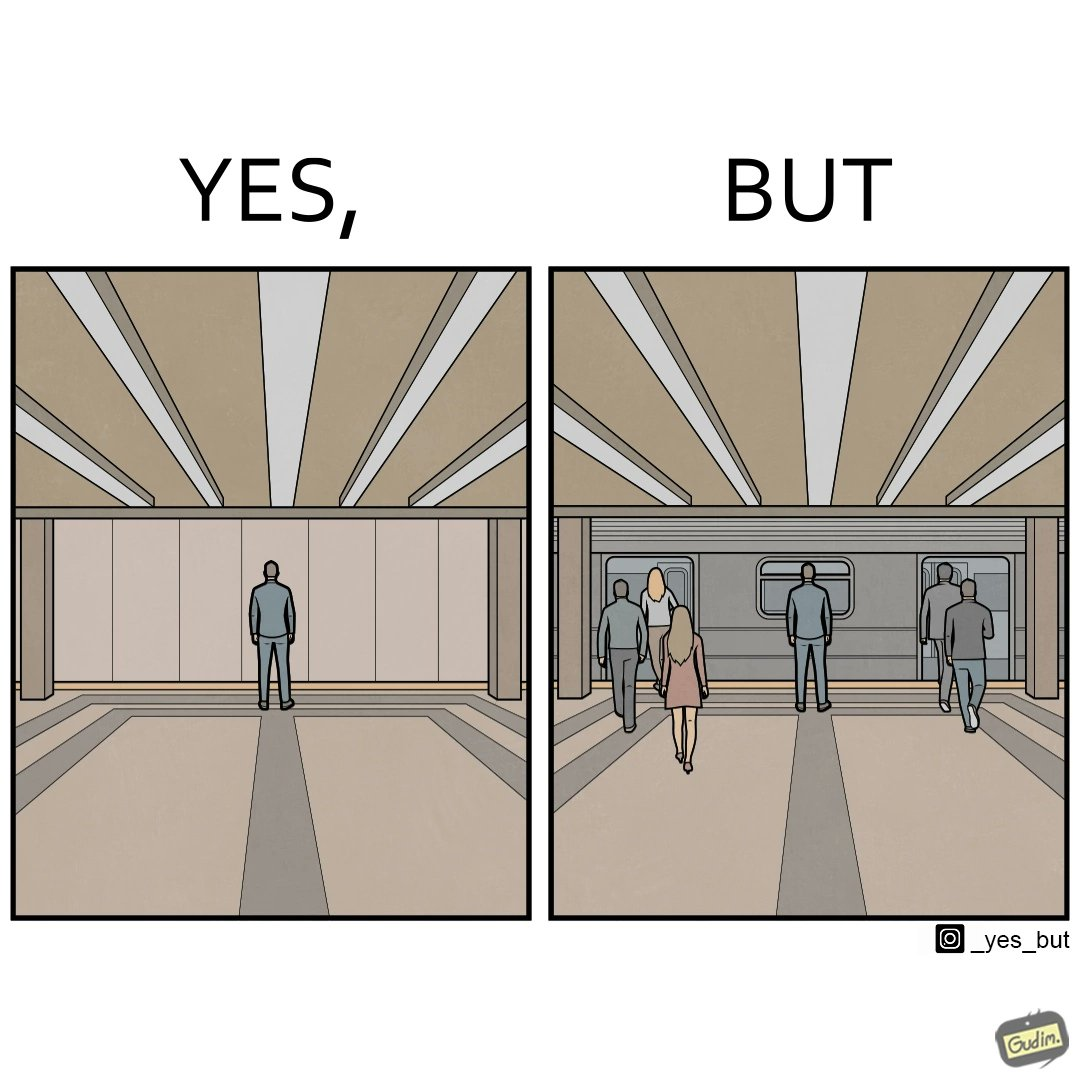Does this image contain satire or humor? Yes, this image is satirical. 